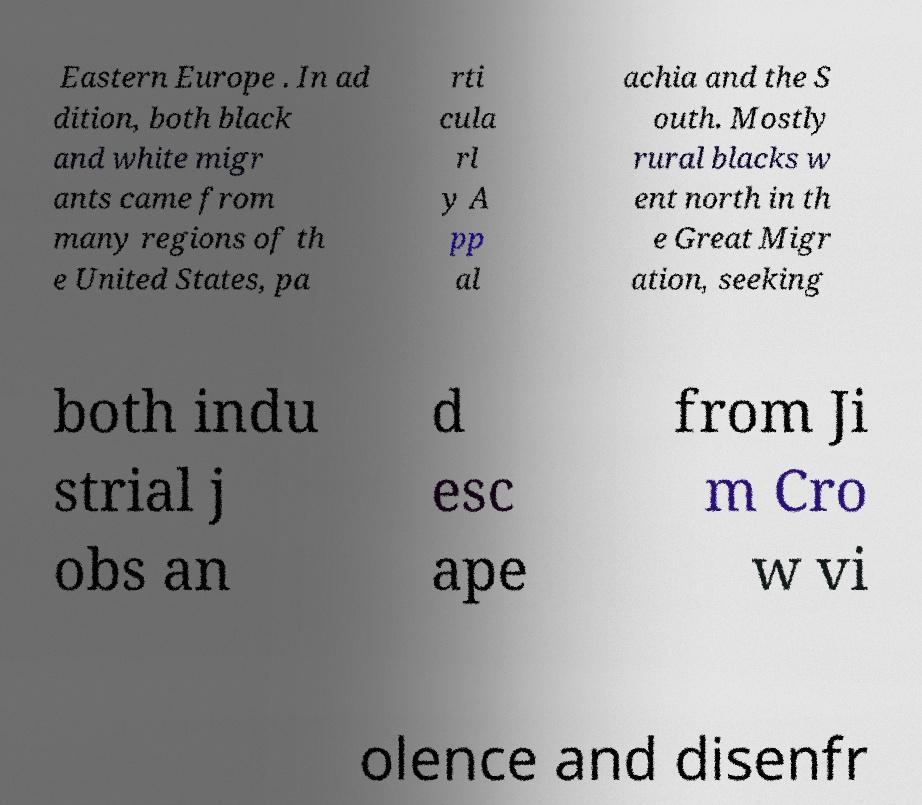Could you assist in decoding the text presented in this image and type it out clearly? Eastern Europe . In ad dition, both black and white migr ants came from many regions of th e United States, pa rti cula rl y A pp al achia and the S outh. Mostly rural blacks w ent north in th e Great Migr ation, seeking both indu strial j obs an d esc ape from Ji m Cro w vi olence and disenfr 